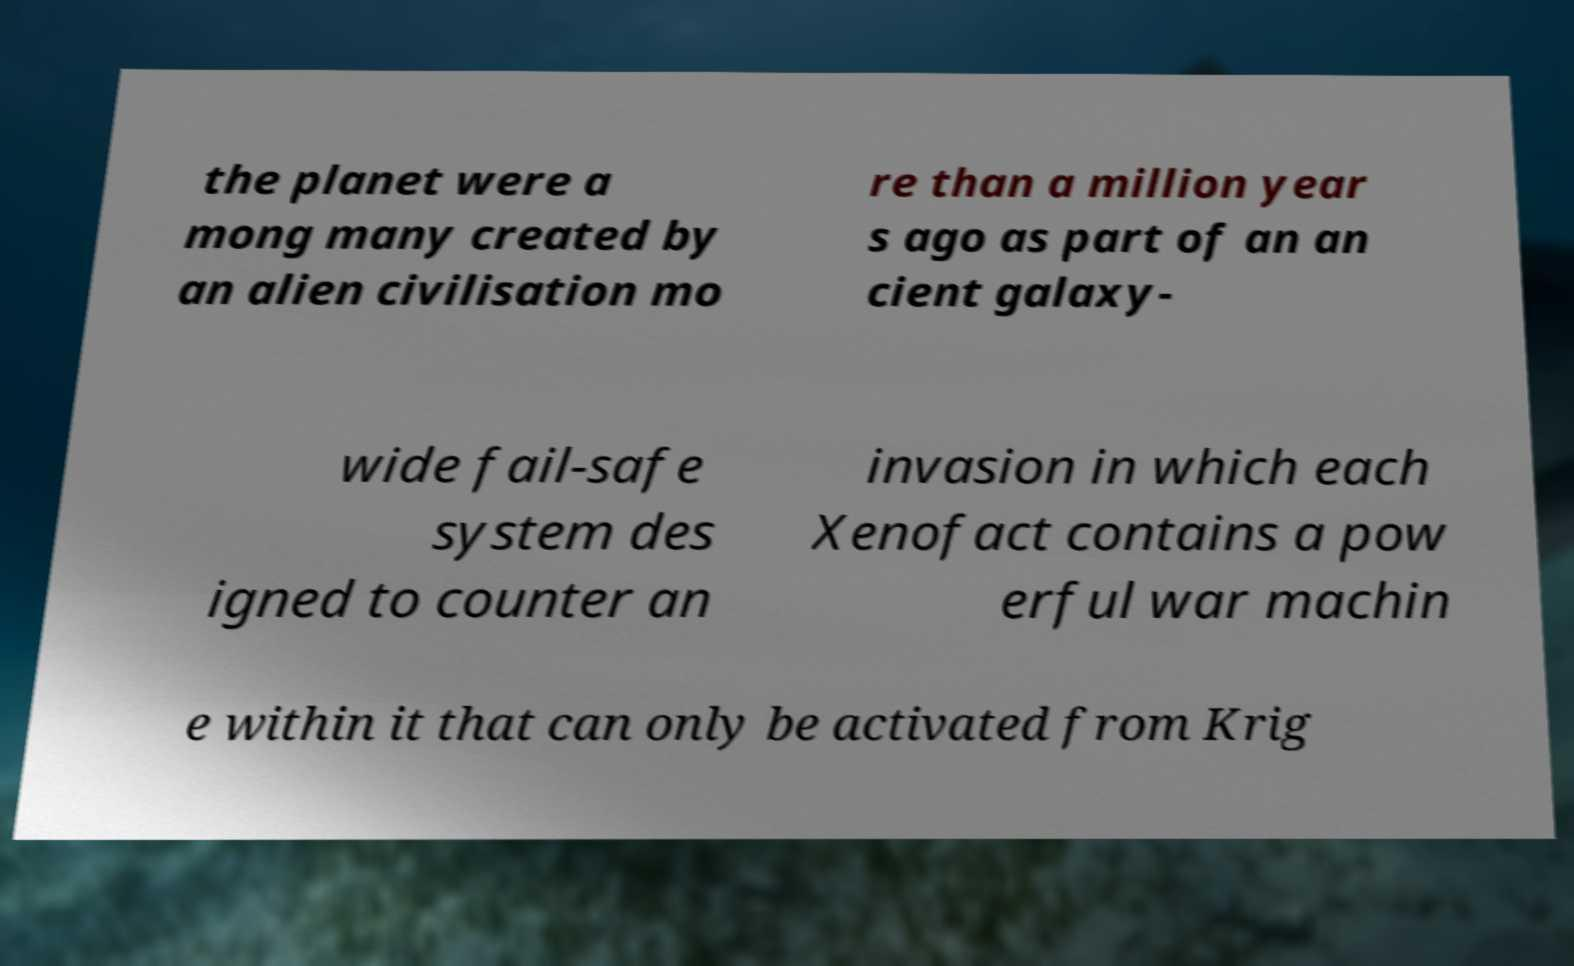There's text embedded in this image that I need extracted. Can you transcribe it verbatim? the planet were a mong many created by an alien civilisation mo re than a million year s ago as part of an an cient galaxy- wide fail-safe system des igned to counter an invasion in which each Xenofact contains a pow erful war machin e within it that can only be activated from Krig 